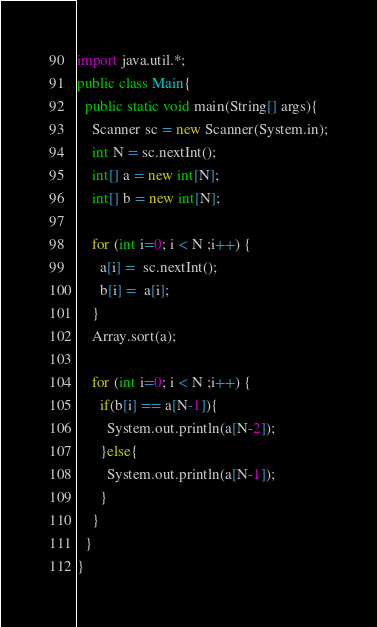<code> <loc_0><loc_0><loc_500><loc_500><_Java_>import java.util.*;
public class Main{
  public static void main(String[] args){
    Scanner sc = new Scanner(System.in);
    int N = sc.nextInt(); 
    int[] a = new int[N];  
    int[] b = new int[N];  

    for (int i=0; i < N ;i++) {
      a[i] =  sc.nextInt();
      b[i] =  a[i];
    }
    Array.sort(a);

    for (int i=0; i < N ;i++) {
      if(b[i] == a[N-1]){
        System.out.println(a[N-2]);
      }else{
        System.out.println(a[N-1]);
      }
    }
  }
}


</code> 